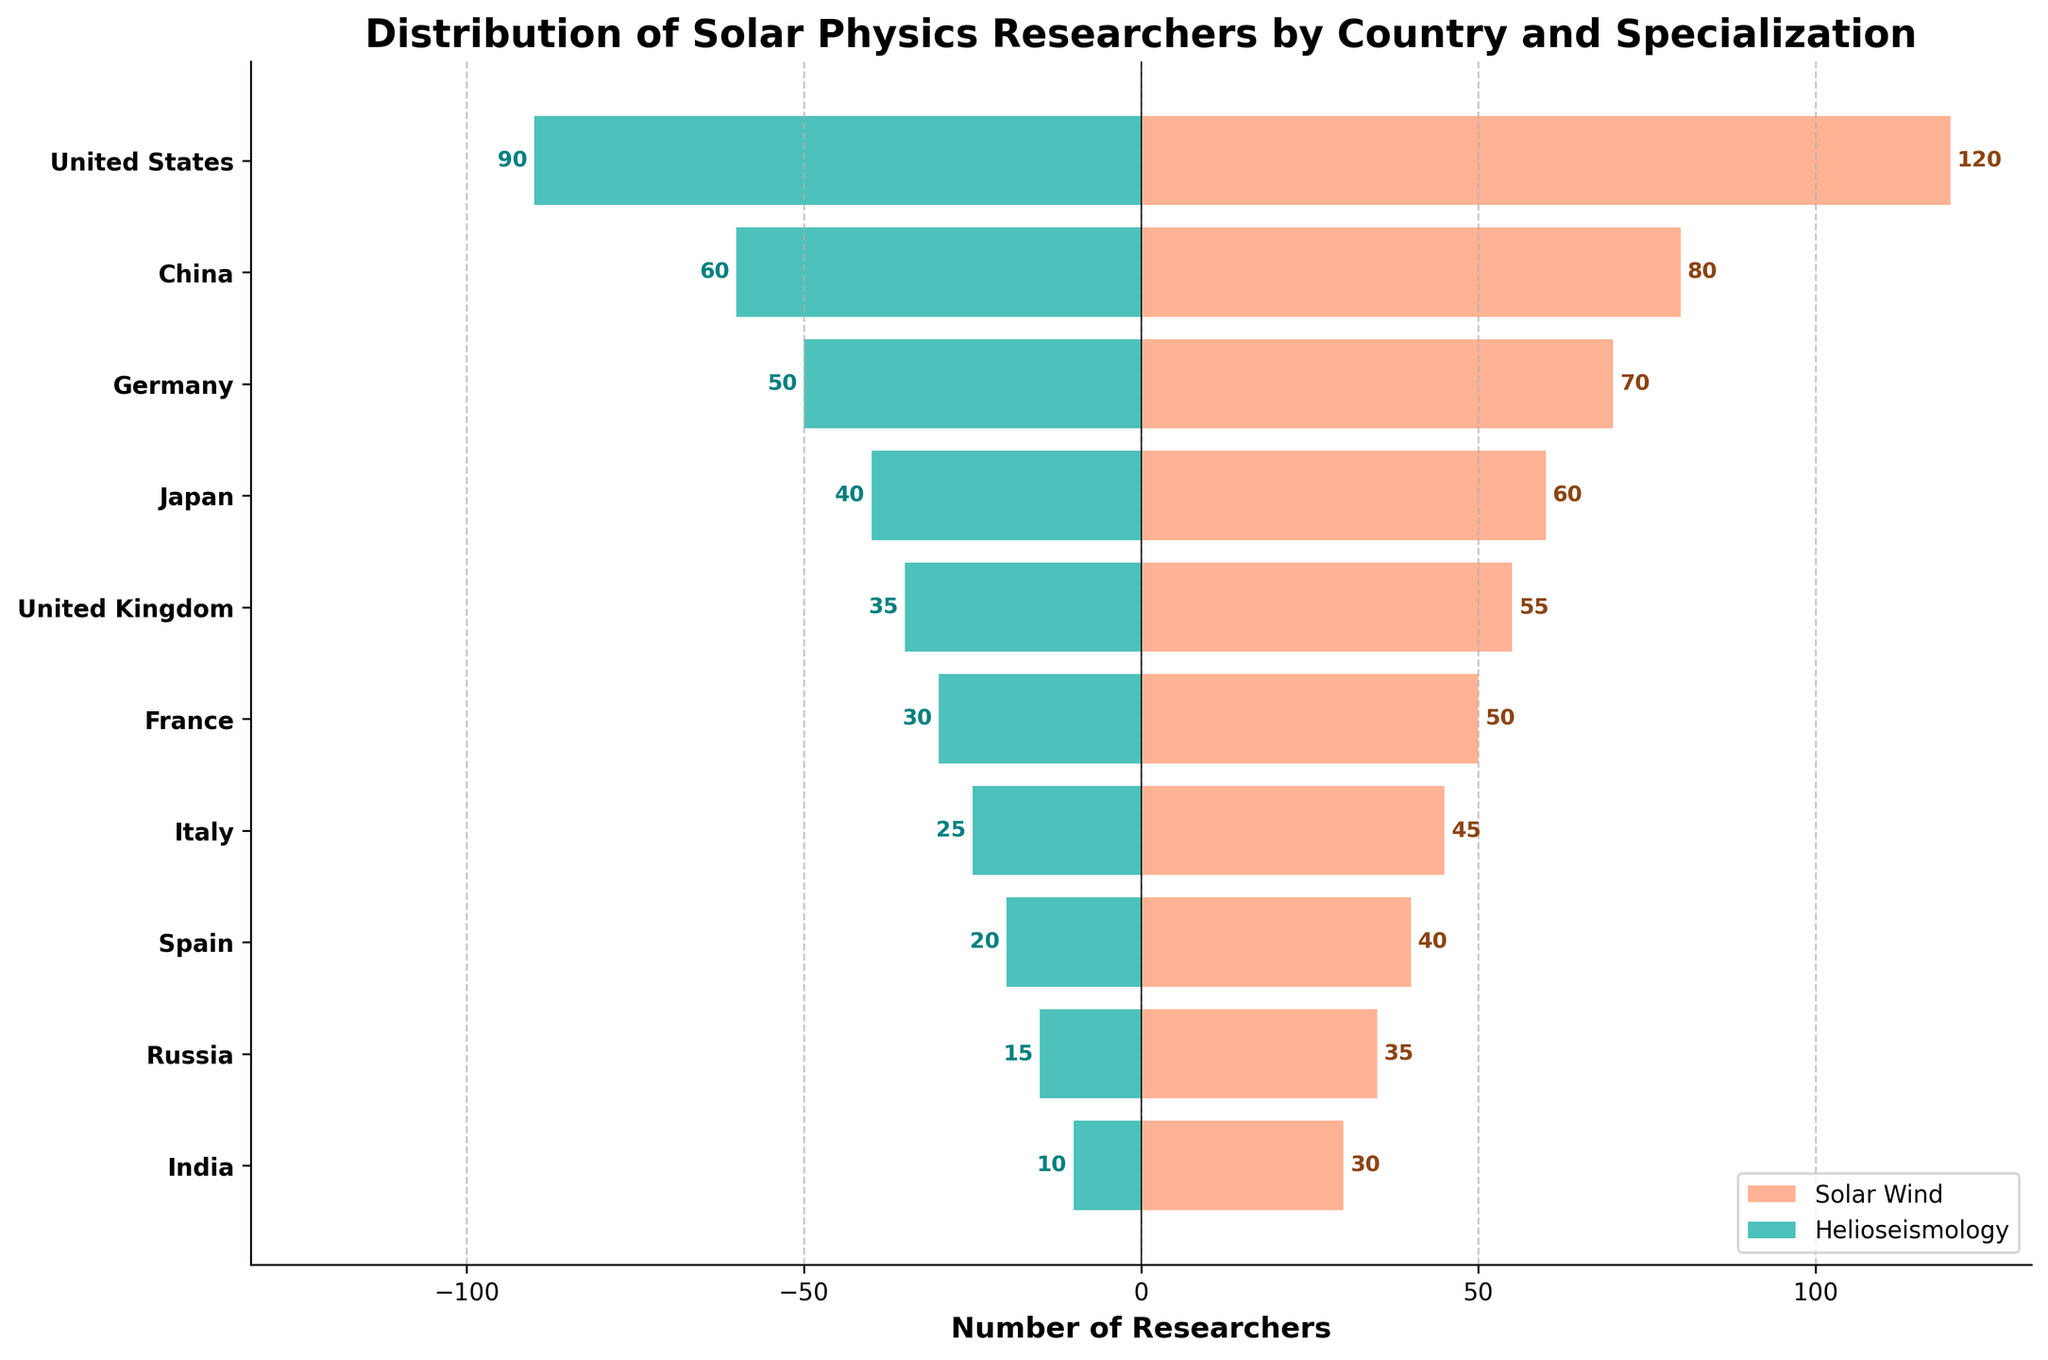Which country has the highest number of Solar Wind researchers? The United States bar in the Solar Wind section is the longest, indicating it has the highest number of researchers in this specialization.
Answer: United States How many researchers are specialized in Helioseismology in Japan? The bar representing Japan for Helioseismology extends to -40, indicating 40 researchers.
Answer: 40 What is the total number of researchers in Germany across both specializations? Germany has 70 researchers in Solar Wind and 50 in Helioseismology. Summing these values gives 70 + 50.
Answer: 120 Which country has more Helioseismology researchers: India or Russia? India has a Helioseismology bar extending to -10, while Russia's Helioseismology bar extends to -15, meaning Russia has more researchers.
Answer: Russia How does the number of Solar Wind researchers in France compare to those in Spain? France has a Solar Wind bar at 50, while Spain's is at 40. Thus, France has more Solar Wind researchers than Spain.
Answer: France What is the difference in the number of Helioseismology researchers between the United Kingdom and Italy? The United Kingdom has 35 Helioseismology researchers, and Italy has 25. The difference is 35 - 25.
Answer: 10 What's the approximate total number of researchers in the United States? The United States has 120 Solar Wind researchers and 90 Helioseismology researchers. Summing these values gives 120 + 90.
Answer: 210 Which specialization has more researchers in China? China's Solar Wind bar extends to 80, while the Helioseismology bar extends to 60. Therefore, Solar Wind has more researchers.
Answer: Solar Wind What's the combined number of Helioseismology researchers in China and Germany? China has 60 Helioseismology researchers, and Germany has 50. Summing these values gives 60 + 50.
Answer: 110 How do the number of Solar Wind researchers in the United Kingdom and Japan compare? The Solar Wind bar for the United Kingdom extends to 55, while Japan's extends to 60, indicating Japan has more researchers in Solar Wind.
Answer: Japan 